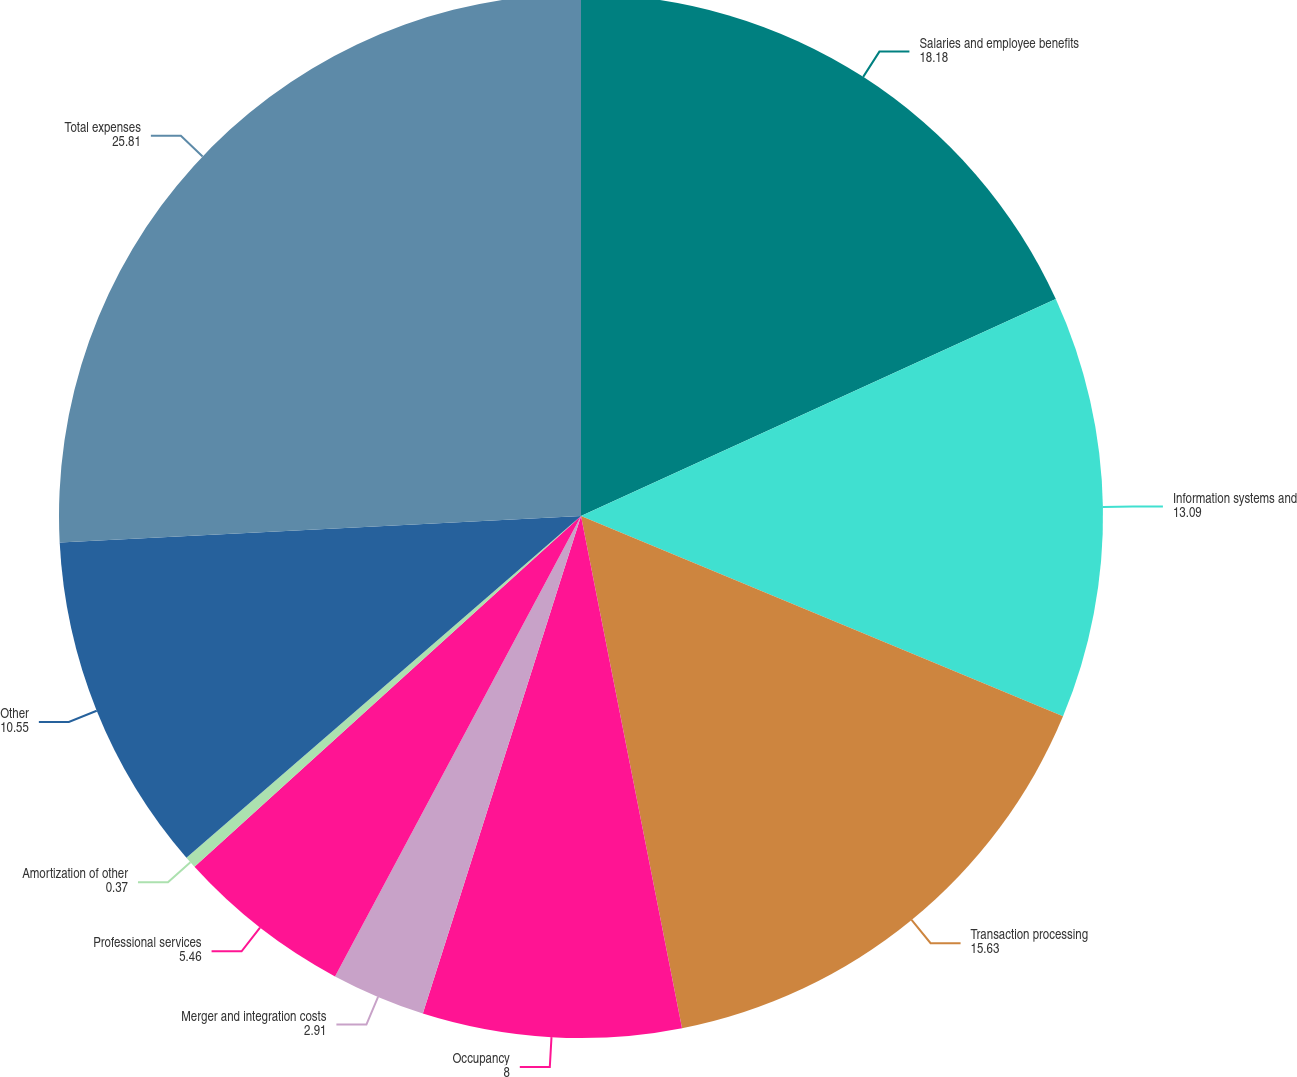<chart> <loc_0><loc_0><loc_500><loc_500><pie_chart><fcel>Salaries and employee benefits<fcel>Information systems and<fcel>Transaction processing<fcel>Occupancy<fcel>Merger and integration costs<fcel>Professional services<fcel>Amortization of other<fcel>Other<fcel>Total expenses<nl><fcel>18.18%<fcel>13.09%<fcel>15.63%<fcel>8.0%<fcel>2.91%<fcel>5.46%<fcel>0.37%<fcel>10.55%<fcel>25.81%<nl></chart> 